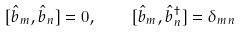Convert formula to latex. <formula><loc_0><loc_0><loc_500><loc_500>[ \hat { b } _ { m } , \hat { b } _ { n } ] = 0 , \quad [ \hat { b } _ { m } , \hat { b } _ { n } ^ { \dagger } ] = \delta _ { m n }</formula> 